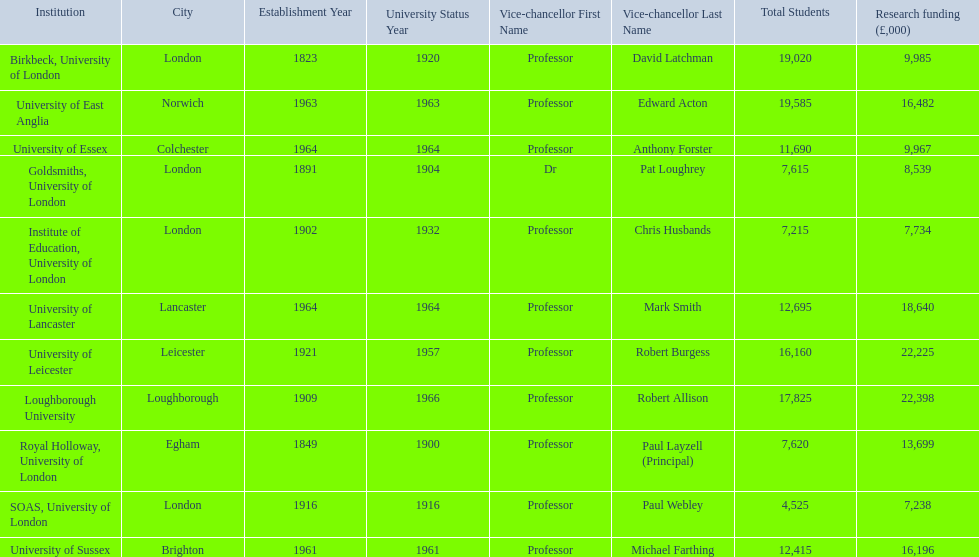Where is birbeck,university of london located? London. Which university was established in 1921? University of Leicester. Which institution gained university status recently? Loughborough University. 